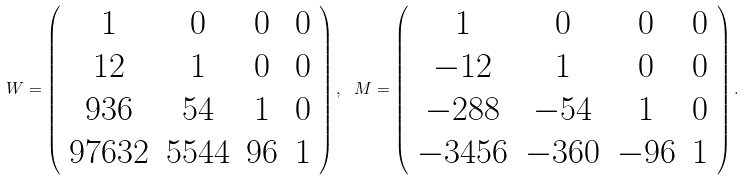<formula> <loc_0><loc_0><loc_500><loc_500>W = \left ( \begin{array} { c c c c } 1 & 0 & 0 & 0 \\ 1 2 & 1 & 0 & 0 \\ 9 3 6 & 5 4 & 1 & 0 \\ 9 7 6 3 2 & 5 5 4 4 & 9 6 & 1 \\ \end{array} \right ) , \ M = \left ( \begin{array} { c c c c } 1 & 0 & 0 & 0 \\ - 1 2 & 1 & 0 & 0 \\ - 2 8 8 & - 5 4 & 1 & 0 \\ - 3 4 5 6 & - 3 6 0 & - 9 6 & 1 \\ \end{array} \right ) .</formula> 